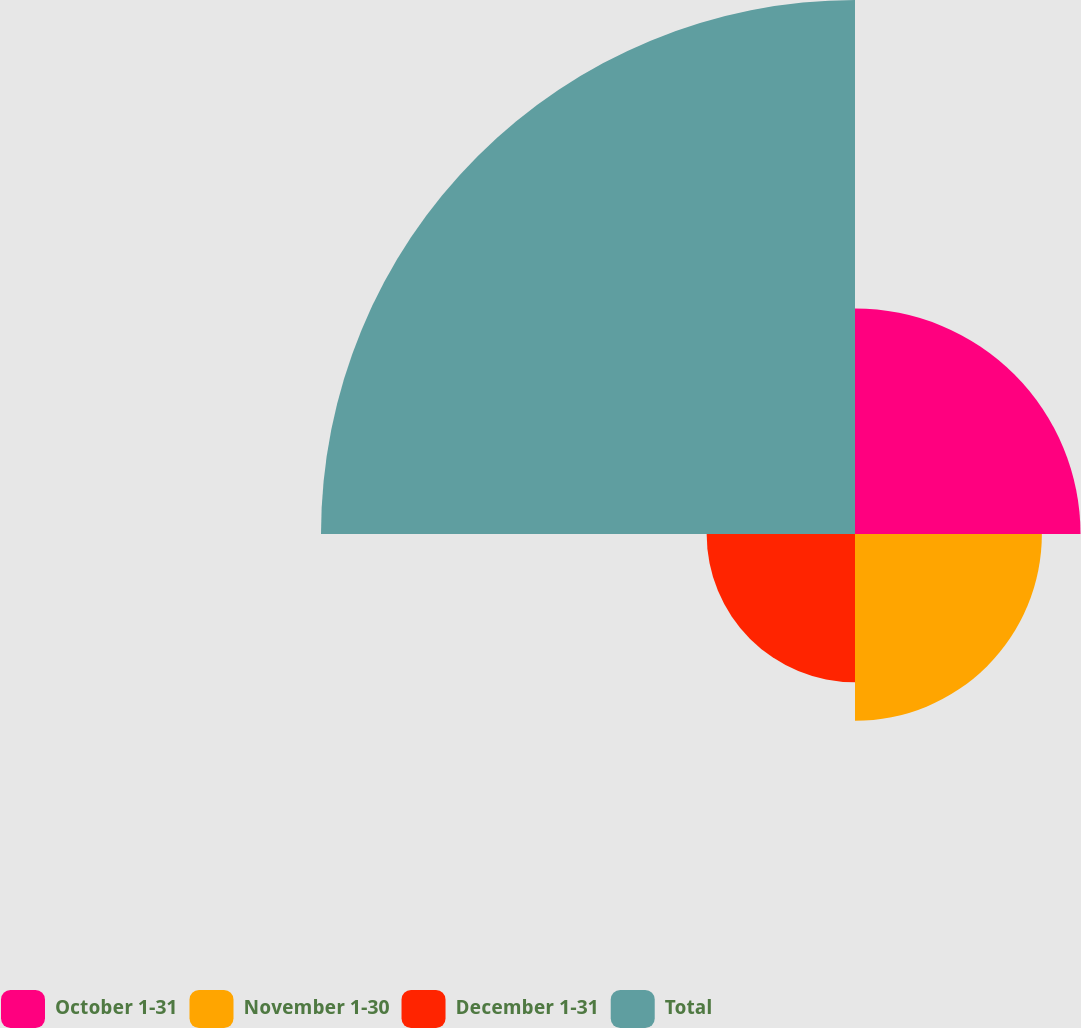Convert chart to OTSL. <chart><loc_0><loc_0><loc_500><loc_500><pie_chart><fcel>October 1-31<fcel>November 1-30<fcel>December 1-31<fcel>Total<nl><fcel>20.6%<fcel>17.07%<fcel>13.55%<fcel>48.78%<nl></chart> 